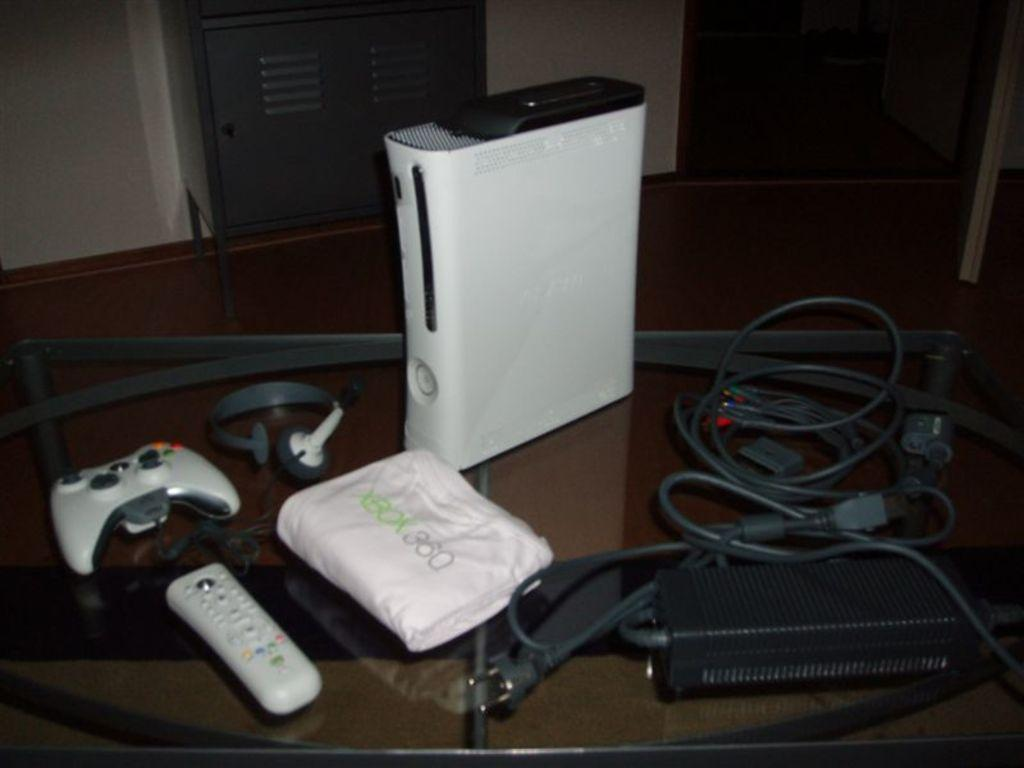<image>
Describe the image concisely. A shirt that says xbox 360 sits on a table with all the things for the xbox gaming system 